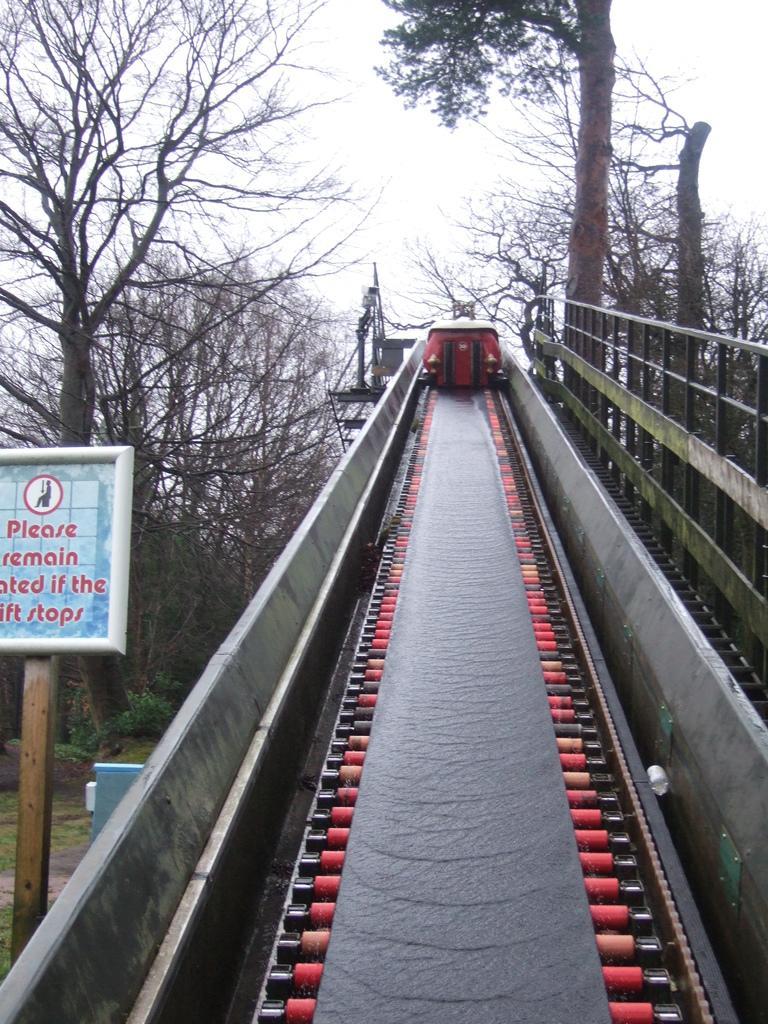In one or two sentences, can you explain what this image depicts? In the center of the picture it is lift. On the right there is hand railing. On the left there is a board. In the background there are trees and sky. 